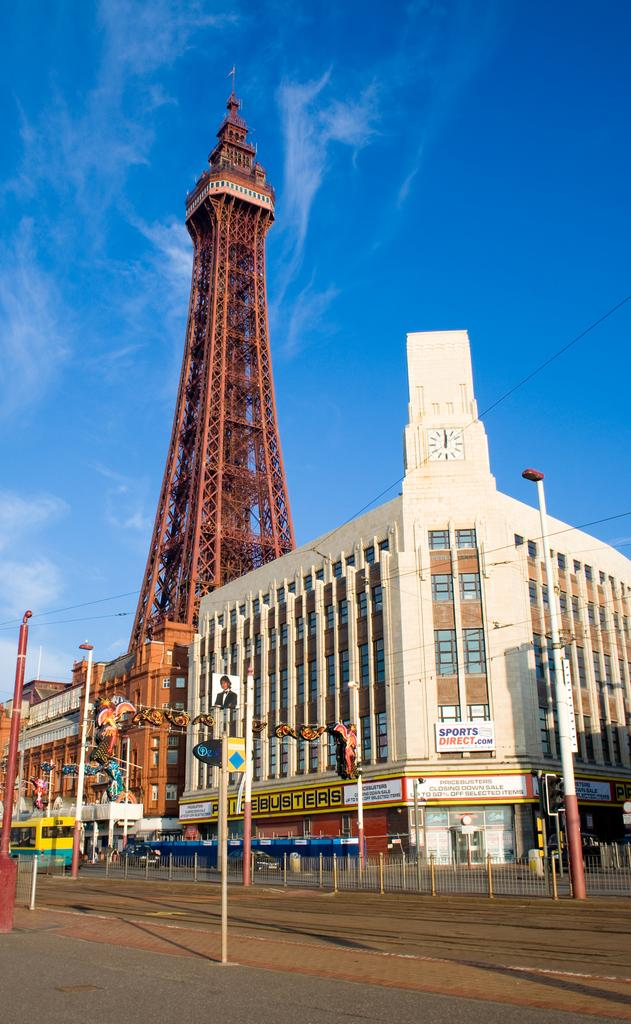What is in the foreground of the image? In the foreground of the image, there is a road, a pavement, bollards, and a pole. What can be seen in the background of the image? In the background of the image, there are buildings, boards, a tower, and the sky. What is the condition of the sky in the image? The sky is visible in the background of the image, and clouds are present. Can you tell me how many times the person in the image helps the dog? There is no person or dog present in the image; it features a road, pavement, bollards, a pole, buildings, boards, a tower, and the sky. What type of kiss is being exchanged between the two people in the image? There are no people present in the image, and therefore no kiss can be observed. 